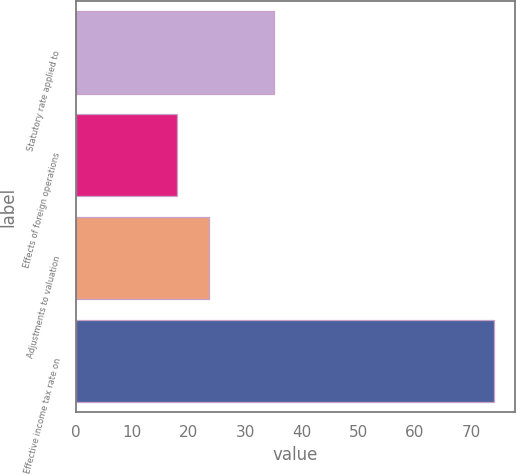<chart> <loc_0><loc_0><loc_500><loc_500><bar_chart><fcel>Statutory rate applied to<fcel>Effects of foreign operations<fcel>Adjustments to valuation<fcel>Effective income tax rate on<nl><fcel>35<fcel>18<fcel>23.6<fcel>74<nl></chart> 